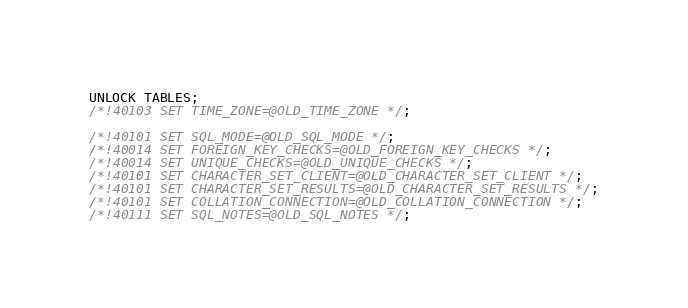<code> <loc_0><loc_0><loc_500><loc_500><_SQL_>UNLOCK TABLES;
/*!40103 SET TIME_ZONE=@OLD_TIME_ZONE */;

/*!40101 SET SQL_MODE=@OLD_SQL_MODE */;
/*!40014 SET FOREIGN_KEY_CHECKS=@OLD_FOREIGN_KEY_CHECKS */;
/*!40014 SET UNIQUE_CHECKS=@OLD_UNIQUE_CHECKS */;
/*!40101 SET CHARACTER_SET_CLIENT=@OLD_CHARACTER_SET_CLIENT */;
/*!40101 SET CHARACTER_SET_RESULTS=@OLD_CHARACTER_SET_RESULTS */;
/*!40101 SET COLLATION_CONNECTION=@OLD_COLLATION_CONNECTION */;
/*!40111 SET SQL_NOTES=@OLD_SQL_NOTES */;

</code> 